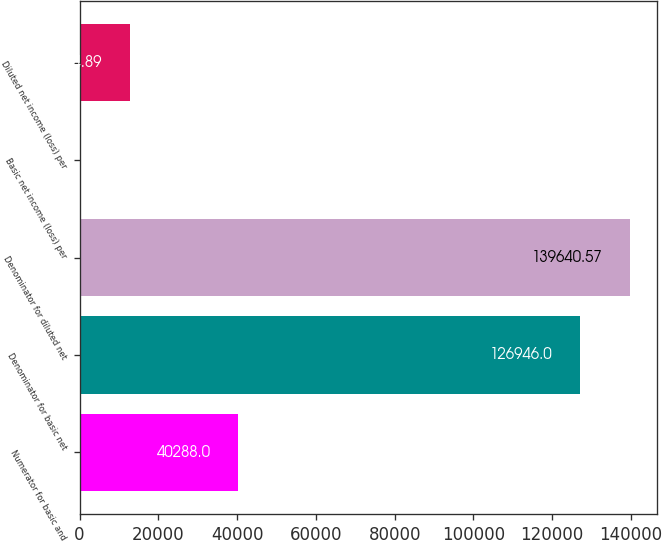Convert chart to OTSL. <chart><loc_0><loc_0><loc_500><loc_500><bar_chart><fcel>Numerator for basic and<fcel>Denominator for basic net<fcel>Denominator for diluted net<fcel>Basic net income (loss) per<fcel>Diluted net income (loss) per<nl><fcel>40288<fcel>126946<fcel>139641<fcel>0.32<fcel>12694.9<nl></chart> 